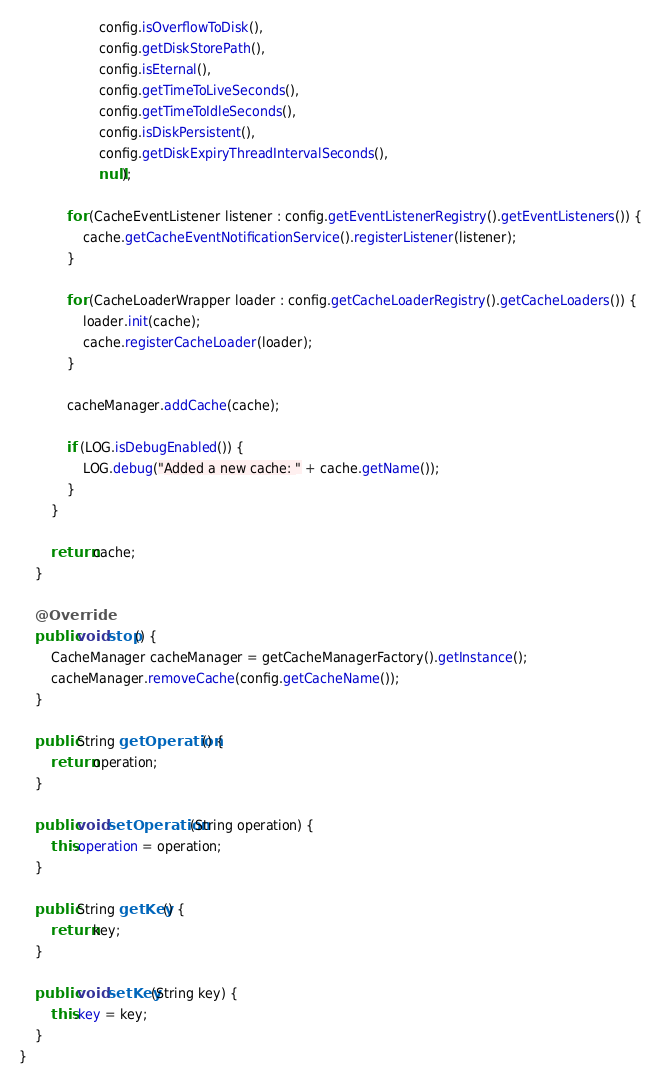<code> <loc_0><loc_0><loc_500><loc_500><_Java_>                    config.isOverflowToDisk(),
                    config.getDiskStorePath(),
                    config.isEternal(),
                    config.getTimeToLiveSeconds(),
                    config.getTimeToIdleSeconds(),
                    config.isDiskPersistent(),
                    config.getDiskExpiryThreadIntervalSeconds(),
                    null);

            for (CacheEventListener listener : config.getEventListenerRegistry().getEventListeners()) {
                cache.getCacheEventNotificationService().registerListener(listener);
            }

            for (CacheLoaderWrapper loader : config.getCacheLoaderRegistry().getCacheLoaders()) {
                loader.init(cache);
                cache.registerCacheLoader(loader);
            }

            cacheManager.addCache(cache);

            if (LOG.isDebugEnabled()) {
                LOG.debug("Added a new cache: " + cache.getName());
            }
        }

        return cache;
    }

    @Override
    public void stop() {
        CacheManager cacheManager = getCacheManagerFactory().getInstance();
        cacheManager.removeCache(config.getCacheName());
    }

    public String getOperation() {
        return operation;
    }

    public void setOperation(String operation) {
        this.operation = operation;
    }

    public String getKey() {
        return key;
    }

    public void setKey(String key) {
        this.key = key;
    }
}
</code> 